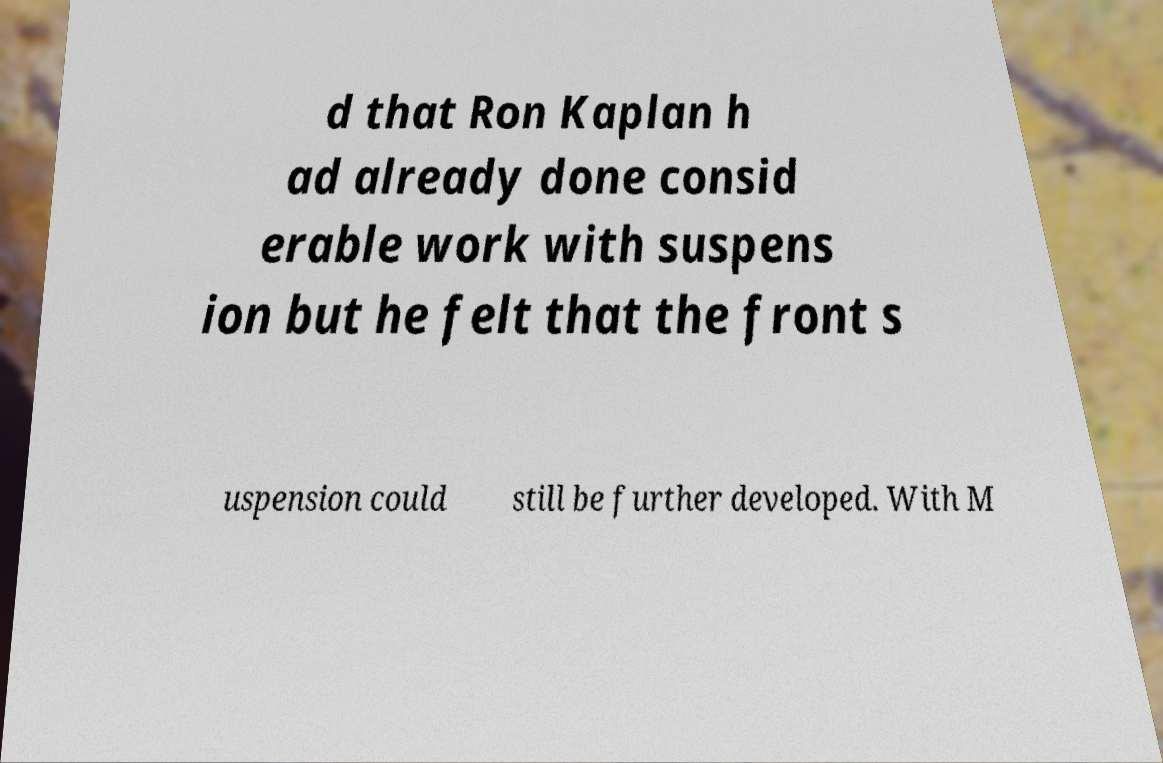Could you extract and type out the text from this image? d that Ron Kaplan h ad already done consid erable work with suspens ion but he felt that the front s uspension could still be further developed. With M 